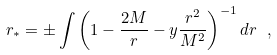Convert formula to latex. <formula><loc_0><loc_0><loc_500><loc_500>r _ { \ast } = \pm \int \left ( 1 - \frac { 2 M } { r } - y \frac { r ^ { 2 } } { M ^ { 2 } } \right ) ^ { - 1 } d r \ ,</formula> 